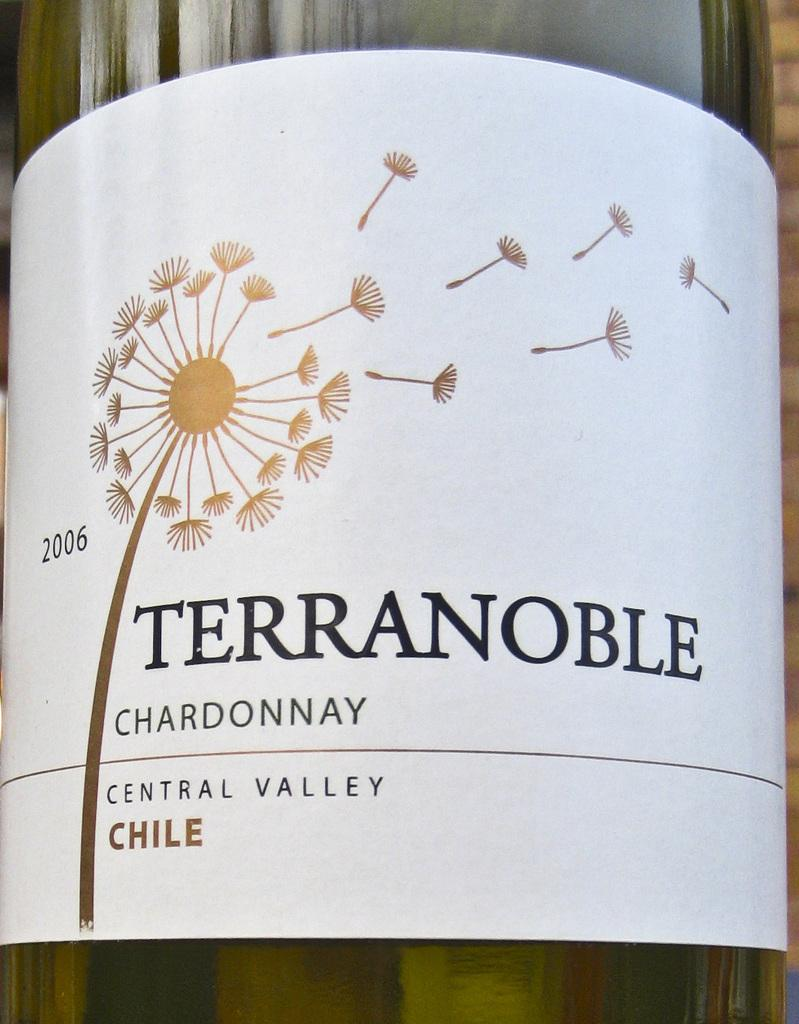<image>
Share a concise interpretation of the image provided. The brand of Chardonnay shown is made in the Central Valley of Chile. 